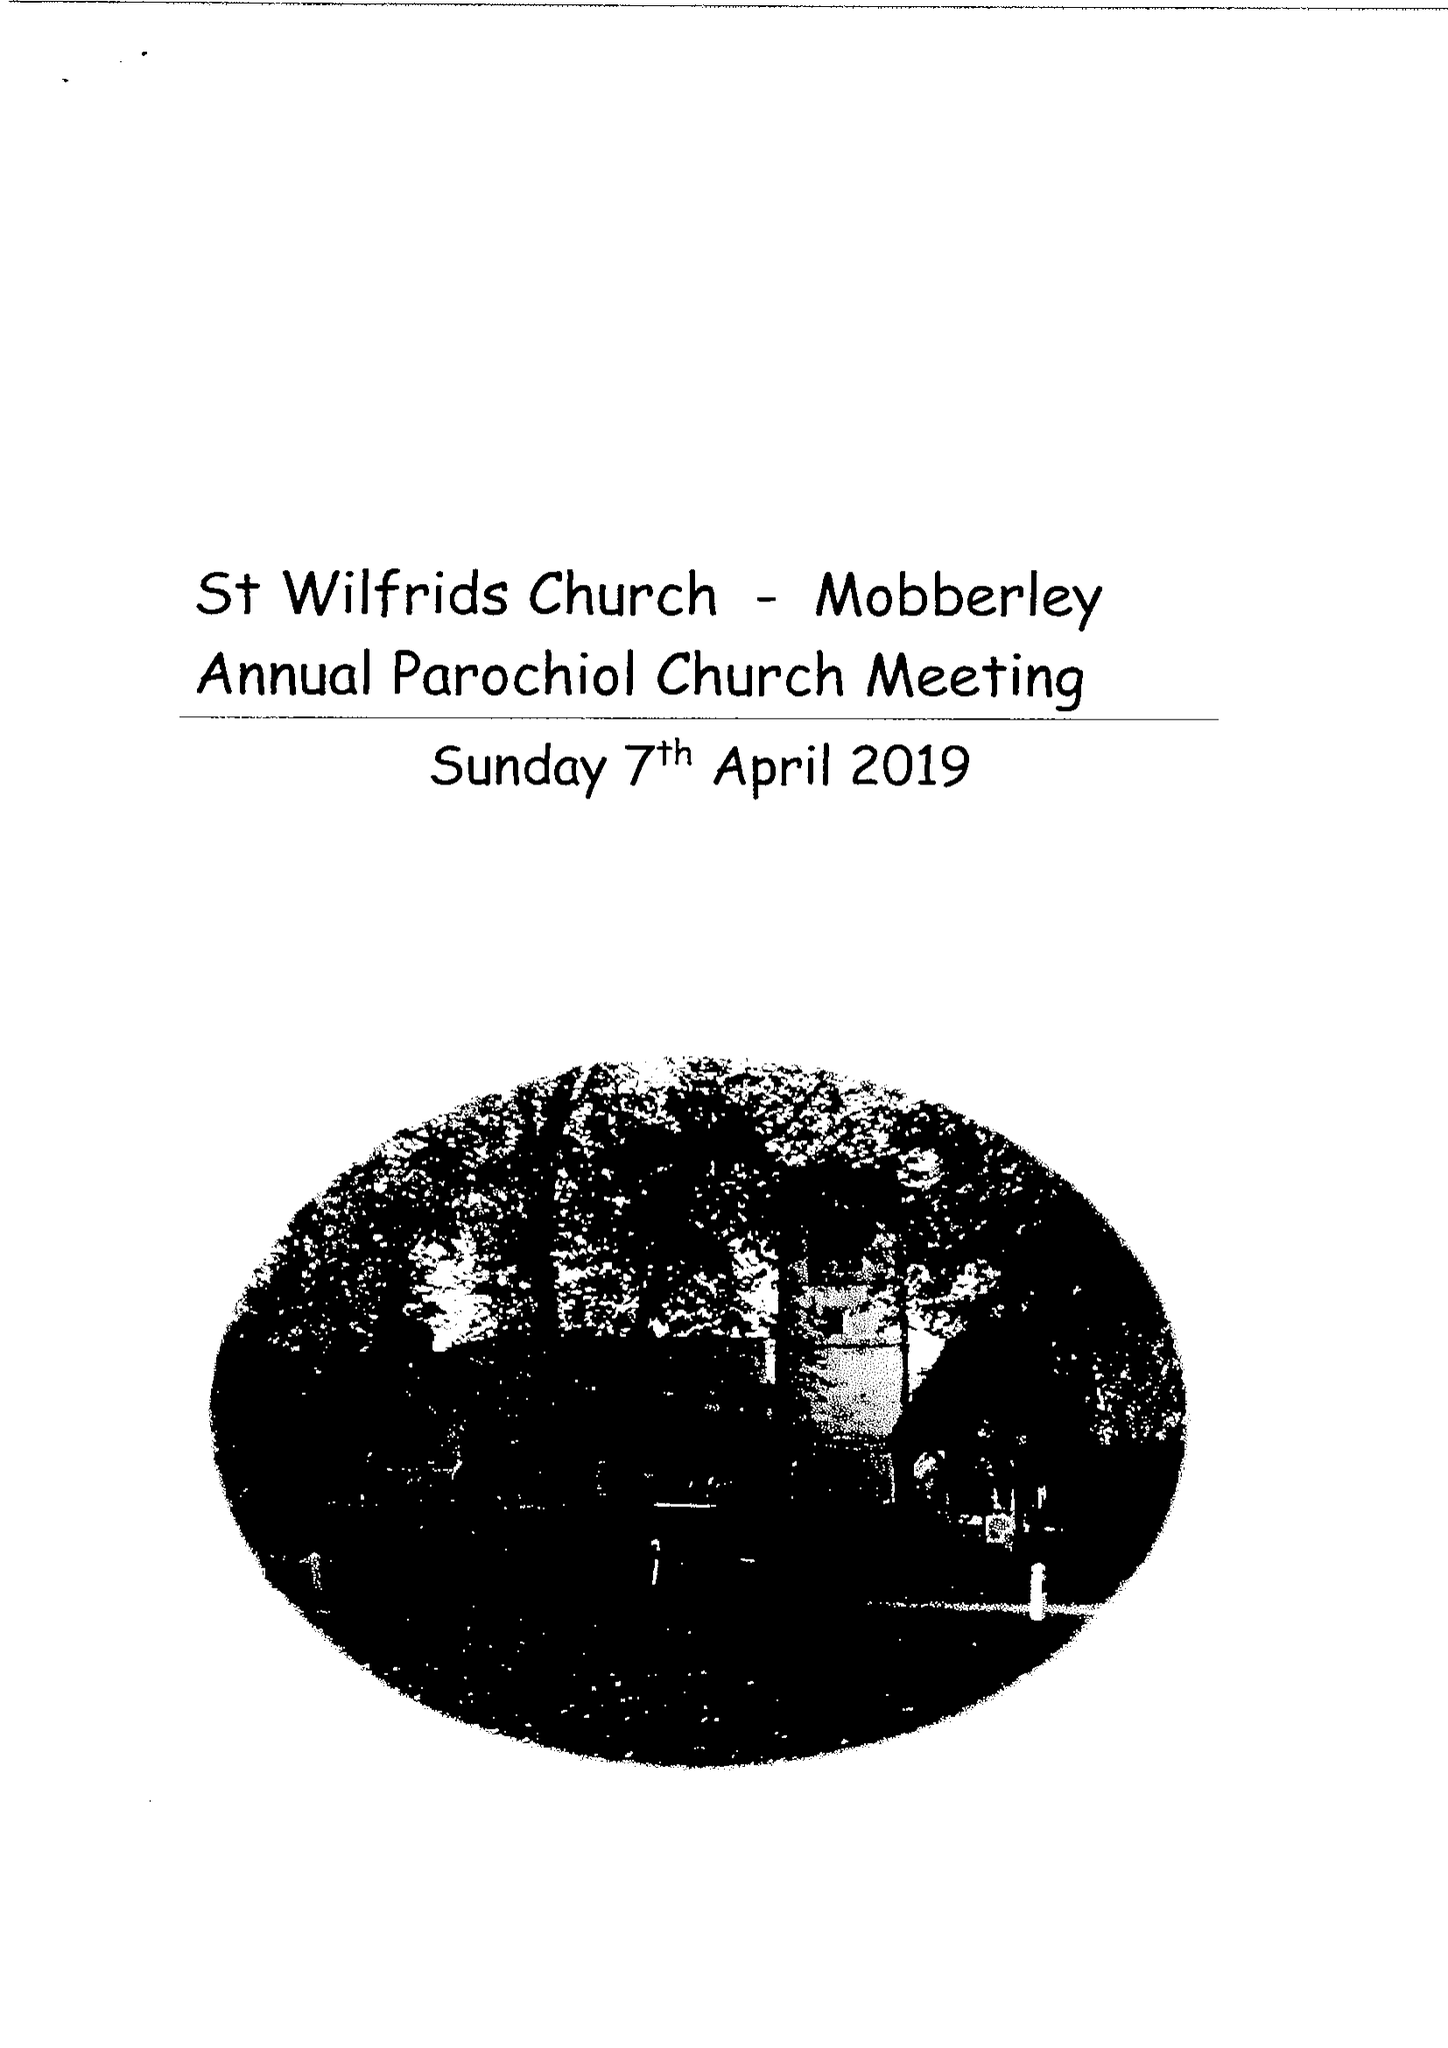What is the value for the income_annually_in_british_pounds?
Answer the question using a single word or phrase. 112247.00 